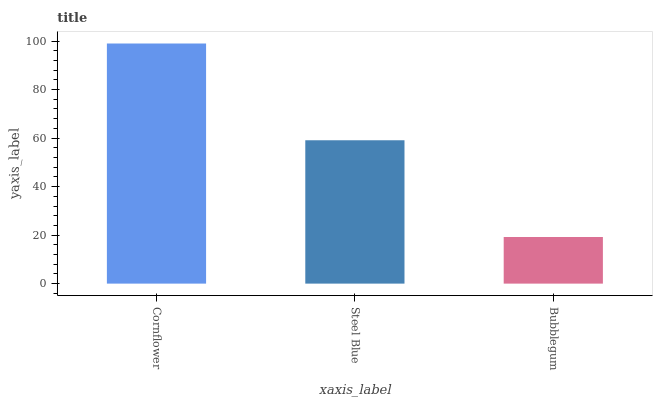Is Bubblegum the minimum?
Answer yes or no. Yes. Is Cornflower the maximum?
Answer yes or no. Yes. Is Steel Blue the minimum?
Answer yes or no. No. Is Steel Blue the maximum?
Answer yes or no. No. Is Cornflower greater than Steel Blue?
Answer yes or no. Yes. Is Steel Blue less than Cornflower?
Answer yes or no. Yes. Is Steel Blue greater than Cornflower?
Answer yes or no. No. Is Cornflower less than Steel Blue?
Answer yes or no. No. Is Steel Blue the high median?
Answer yes or no. Yes. Is Steel Blue the low median?
Answer yes or no. Yes. Is Bubblegum the high median?
Answer yes or no. No. Is Bubblegum the low median?
Answer yes or no. No. 